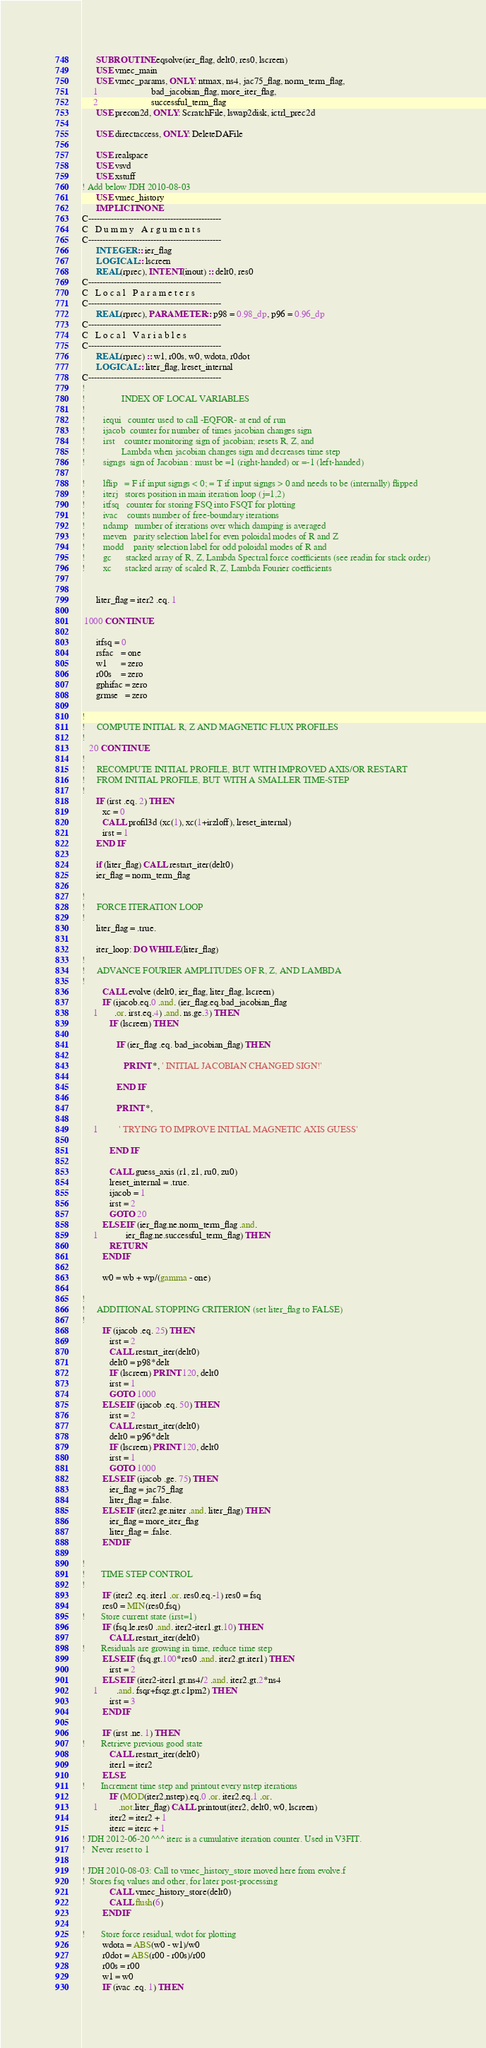<code> <loc_0><loc_0><loc_500><loc_500><_FORTRAN_>      SUBROUTINE eqsolve(ier_flag, delt0, res0, lscreen)
      USE vmec_main
      USE vmec_params, ONLY: ntmax, ns4, jac75_flag, norm_term_flag,
     1                       bad_jacobian_flag, more_iter_flag,
     2                       successful_term_flag
      USE precon2d, ONLY: ScratchFile, lswap2disk, ictrl_prec2d

      USE directaccess, ONLY: DeleteDAFile

      USE realspace
      USE vsvd
      USE xstuff
! Add below JDH 2010-08-03
      USE vmec_history
      IMPLICIT NONE
C-----------------------------------------------
C   D u m m y   A r g u m e n t s
C-----------------------------------------------
      INTEGER :: ier_flag
      LOGICAL :: lscreen
      REAL(rprec), INTENT(inout) :: delt0, res0
C-----------------------------------------------
C   L o c a l   P a r a m e t e r s
C-----------------------------------------------
      REAL(rprec), PARAMETER :: p98 = 0.98_dp, p96 = 0.96_dp
C-----------------------------------------------
C   L o c a l   V a r i a b l e s
C-----------------------------------------------
      REAL(rprec) :: w1, r00s, w0, wdota, r0dot
      LOGICAL :: liter_flag, lreset_internal
C-----------------------------------------------
!
!                INDEX OF LOCAL VARIABLES
!
!        iequi   counter used to call -EQFOR- at end of run
!        ijacob  counter for number of times jacobian changes sign
!        irst    counter monitoring sign of jacobian; resets R, Z, and
!                Lambda when jacobian changes sign and decreases time step
!        signgs  sign of Jacobian : must be =1 (right-handed) or =-1 (left-handed)

!        lflip   = F if input signgs < 0; = T if input signgs > 0 and needs to be (internally) flipped
!        iterj   stores position in main iteration loop (j=1,2)
!        itfsq   counter for storing FSQ into FSQT for plotting
!        ivac    counts number of free-boundary iterations
!        ndamp   number of iterations over which damping is averaged
!        meven   parity selection label for even poloidal modes of R and Z
!        modd    parity selection label for odd poloidal modes of R and
!        gc      stacked array of R, Z, Lambda Spectral force coefficients (see readin for stack order)
!        xc      stacked array of scaled R, Z, Lambda Fourier coefficients


      liter_flag = iter2 .eq. 1

 1000 CONTINUE

      itfsq = 0
      rsfac   = one
      w1      = zero
      r00s    = zero
      gphifac = zero
      grmse   = zero

!
!     COMPUTE INITIAL R, Z AND MAGNETIC FLUX PROFILES
!
   20 CONTINUE
!
!     RECOMPUTE INITIAL PROFILE, BUT WITH IMPROVED AXIS/OR RESTART 
!     FROM INITIAL PROFILE, BUT WITH A SMALLER TIME-STEP
!
      IF (irst .eq. 2) THEN
         xc = 0
         CALL profil3d (xc(1), xc(1+irzloff), lreset_internal)
         irst = 1
      END IF

      if (liter_flag) CALL restart_iter(delt0)
      ier_flag = norm_term_flag

!
!     FORCE ITERATION LOOP
!
      liter_flag = .true.

      iter_loop: DO WHILE (liter_flag)
!
!     ADVANCE FOURIER AMPLITUDES OF R, Z, AND LAMBDA
!
         CALL evolve (delt0, ier_flag, liter_flag, lscreen)
         IF (ijacob.eq.0 .and. (ier_flag.eq.bad_jacobian_flag
     1       .or. irst.eq.4) .and. ns.ge.3) THEN
            IF (lscreen) THEN

               IF (ier_flag .eq. bad_jacobian_flag) THEN

                  PRINT *, ' INITIAL JACOBIAN CHANGED SIGN!'

               END IF

               PRINT *,

     1         ' TRYING TO IMPROVE INITIAL MAGNETIC AXIS GUESS'

            END IF

            CALL guess_axis (r1, z1, ru0, zu0)
            lreset_internal = .true.
            ijacob = 1
            irst = 2
            GOTO 20
         ELSE IF (ier_flag.ne.norm_term_flag .and. 
     1            ier_flag.ne.successful_term_flag) THEN
            RETURN
         ENDIF

         w0 = wb + wp/(gamma - one)

!
!     ADDITIONAL STOPPING CRITERION (set liter_flag to FALSE)
!
         IF (ijacob .eq. 25) THEN
            irst = 2
            CALL restart_iter(delt0)
            delt0 = p98*delt
            IF (lscreen) PRINT 120, delt0
            irst = 1
            GOTO 1000
         ELSE IF (ijacob .eq. 50) THEN
            irst = 2
            CALL restart_iter(delt0)
            delt0 = p96*delt
            IF (lscreen) PRINT 120, delt0
            irst = 1
            GOTO 1000
         ELSE IF (ijacob .ge. 75) THEN
            ier_flag = jac75_flag
            liter_flag = .false.
         ELSE IF (iter2.ge.niter .and. liter_flag) THEN
            ier_flag = more_iter_flag
            liter_flag = .false.
         ENDIF

!
!       TIME STEP CONTROL
!
         IF (iter2 .eq. iter1 .or. res0.eq.-1) res0 = fsq
         res0 = MIN(res0,fsq)
!       Store current state (irst=1)
         IF (fsq.le.res0 .and. iter2-iter1.gt.10) THEN
            CALL restart_iter(delt0)
!       Residuals are growing in time, reduce time step
         ELSE IF (fsq.gt.100*res0 .and. iter2.gt.iter1) THEN
            irst = 2
         ELSE IF (iter2-iter1.gt.ns4/2 .and. iter2.gt.2*ns4
     1        .and. fsqr+fsqz.gt.c1pm2) THEN
            irst = 3
         ENDIF

         IF (irst .ne. 1) THEN
!       Retrieve previous good state
            CALL restart_iter(delt0)
            iter1 = iter2
         ELSE
!       Increment time step and printout every nstep iterations
            IF (MOD(iter2,nstep).eq.0 .or. iter2.eq.1 .or.
     1         .not.liter_flag) CALL printout(iter2, delt0, w0, lscreen)
            iter2 = iter2 + 1
            iterc = iterc + 1
! JDH 2012-06-20 ^^^ iterc is a cumulative iteration counter. Used in V3FIT.
!   Never reset to 1

! JDH 2010-08-03: Call to vmec_history_store moved here from evolve.f
!  Stores fsq values and other, for later post-processing
            CALL vmec_history_store(delt0)
            CALL flush(6)
         ENDIF

!       Store force residual, wdot for plotting
         wdota = ABS(w0 - w1)/w0
         r0dot = ABS(r00 - r00s)/r00
         r00s = r00
         w1 = w0
         IF (ivac .eq. 1) THEN</code> 